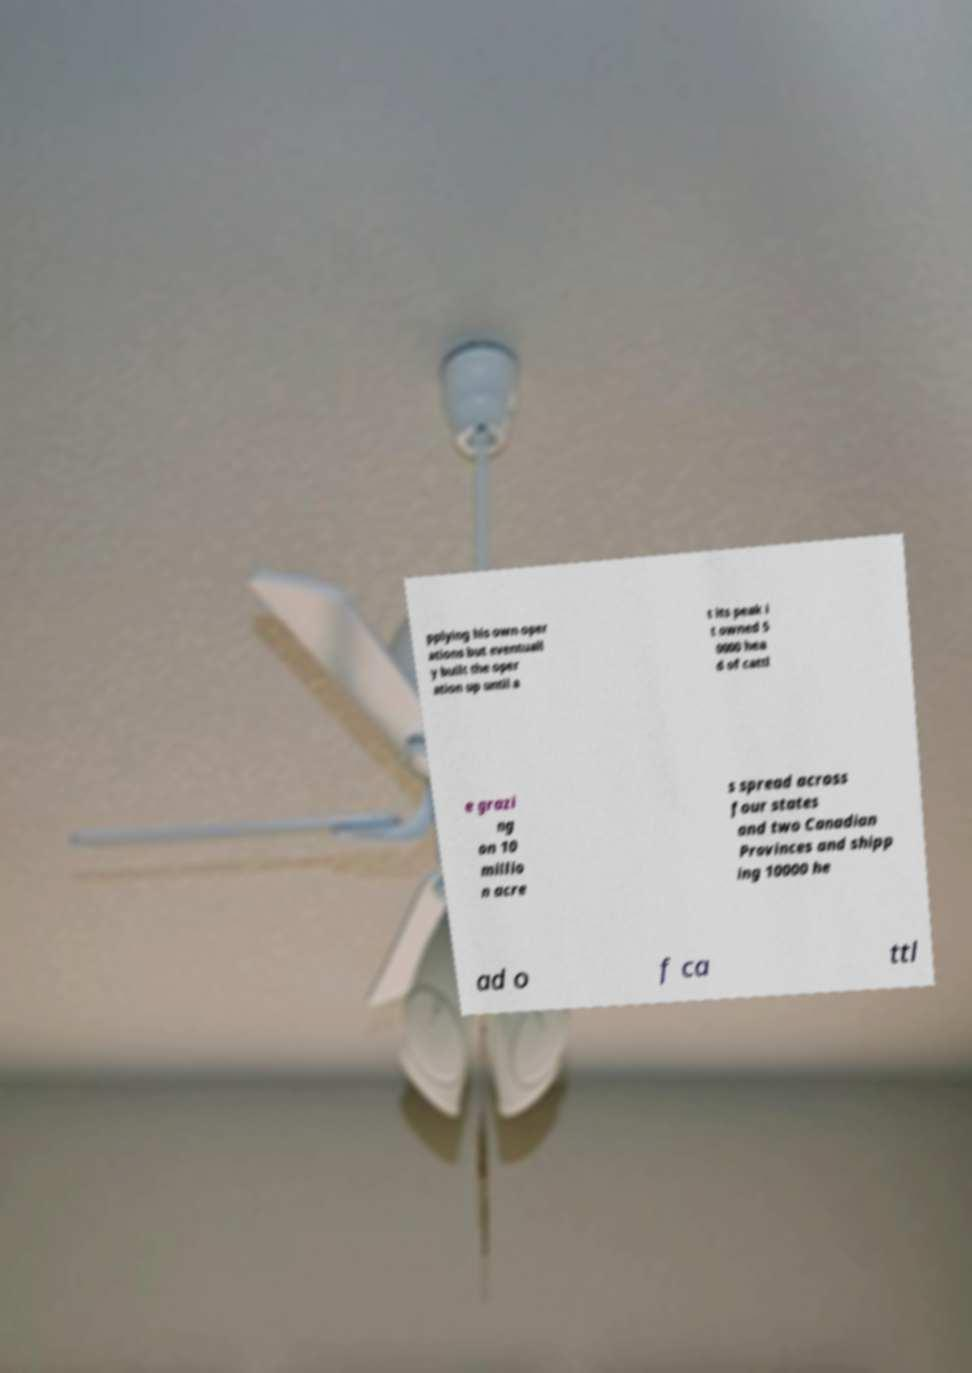I need the written content from this picture converted into text. Can you do that? pplying his own oper ations but eventuall y built the oper ation up until a t its peak i t owned 5 0000 hea d of cattl e grazi ng on 10 millio n acre s spread across four states and two Canadian Provinces and shipp ing 10000 he ad o f ca ttl 